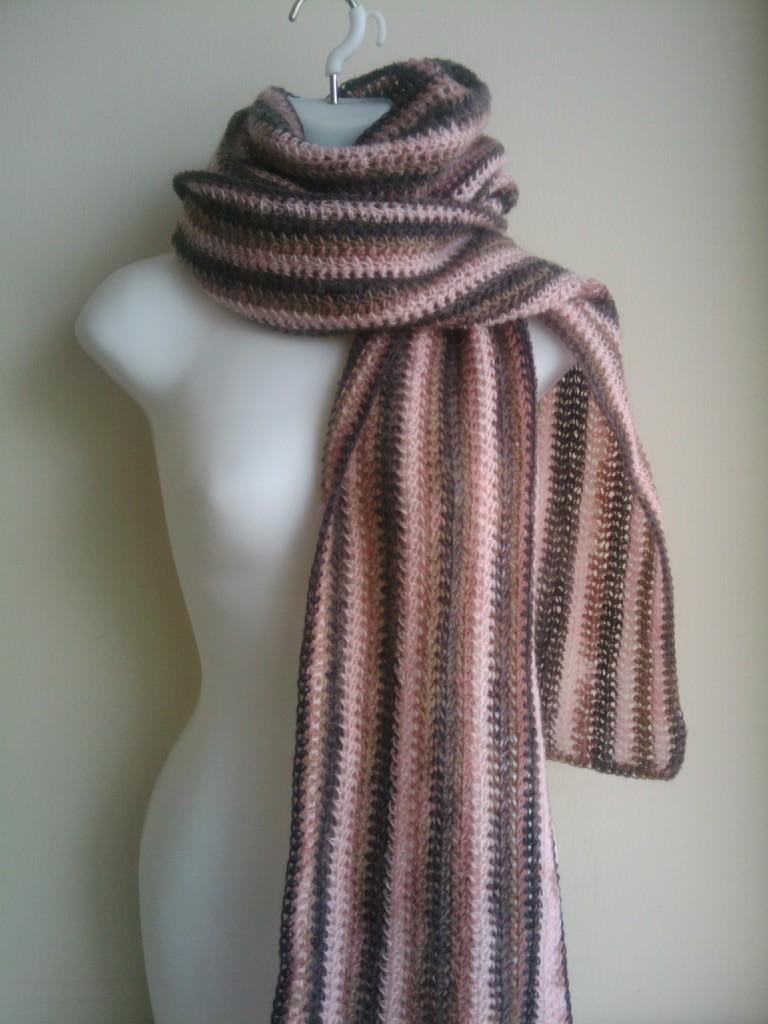Describe this image in one or two sentences. In this image we can see female mannequin which is in white color and there is a stole around the neck of the mannequin. 